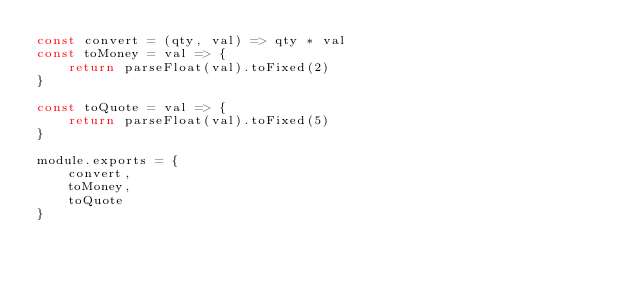Convert code to text. <code><loc_0><loc_0><loc_500><loc_500><_JavaScript_>const convert = (qty, val) => qty * val
const toMoney = val => {
    return parseFloat(val).toFixed(2)
}

const toQuote = val => {
    return parseFloat(val).toFixed(5)
}

module.exports = {
    convert,
    toMoney,
    toQuote
}</code> 